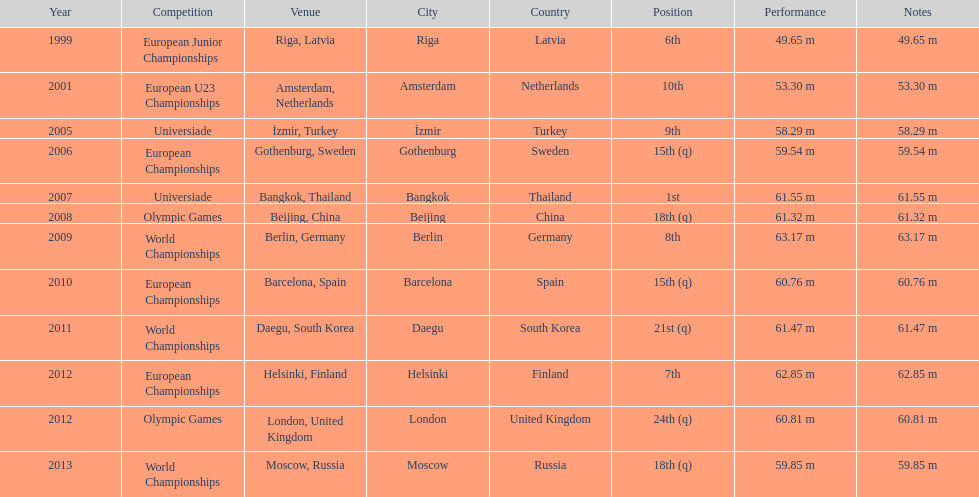What was the longest throw mayer ever achieved as his top result? 63.17 m. 